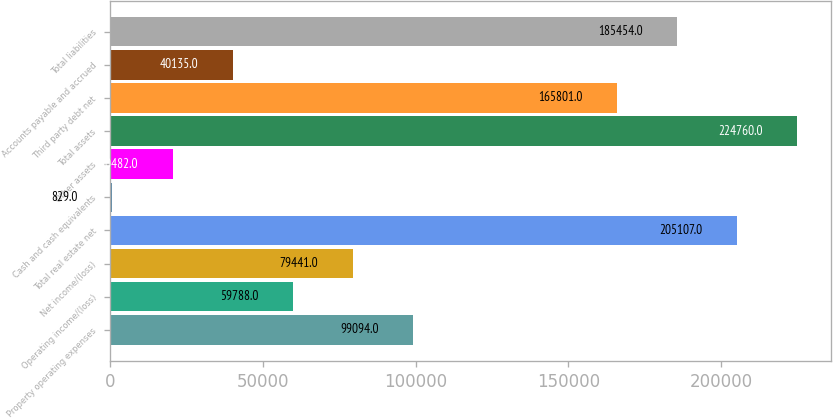Convert chart. <chart><loc_0><loc_0><loc_500><loc_500><bar_chart><fcel>Property operating expenses<fcel>Operating income/(loss)<fcel>Net income/(loss)<fcel>Total real estate net<fcel>Cash and cash equivalents<fcel>Other assets<fcel>Total assets<fcel>Third party debt net<fcel>Accounts payable and accrued<fcel>Total liabilities<nl><fcel>99094<fcel>59788<fcel>79441<fcel>205107<fcel>829<fcel>20482<fcel>224760<fcel>165801<fcel>40135<fcel>185454<nl></chart> 